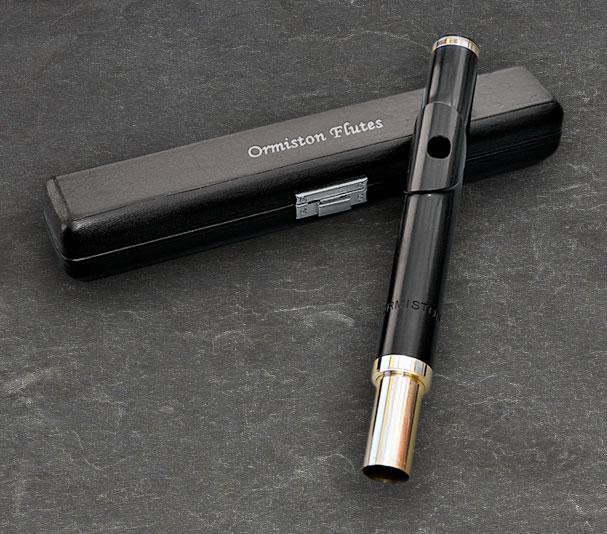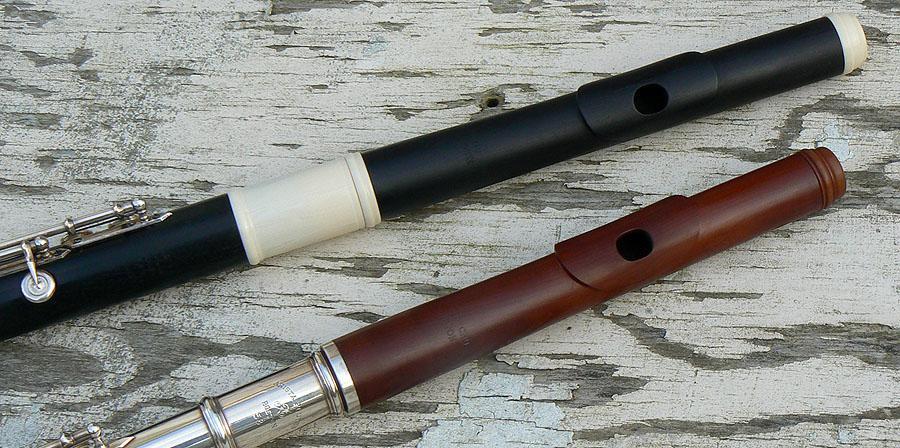The first image is the image on the left, the second image is the image on the right. For the images displayed, is the sentence "In at least one image there is a single close flute case sitting on the ground." factually correct? Answer yes or no. Yes. 